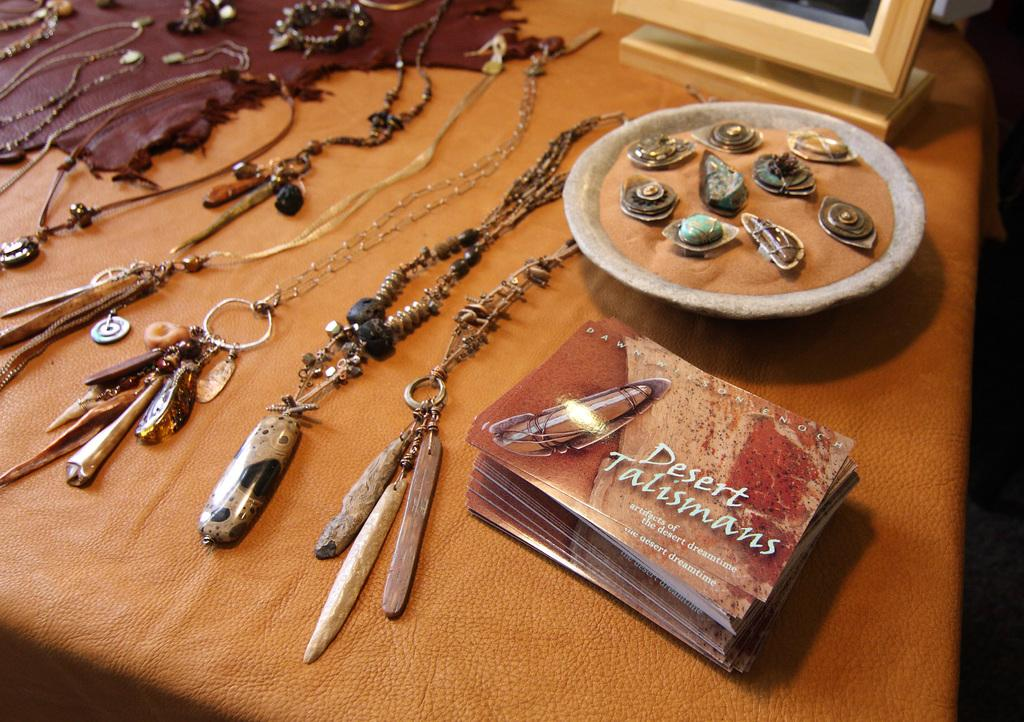<image>
Write a terse but informative summary of the picture. A small book of Desert Talismans sits on a table with different stones and crystals. 